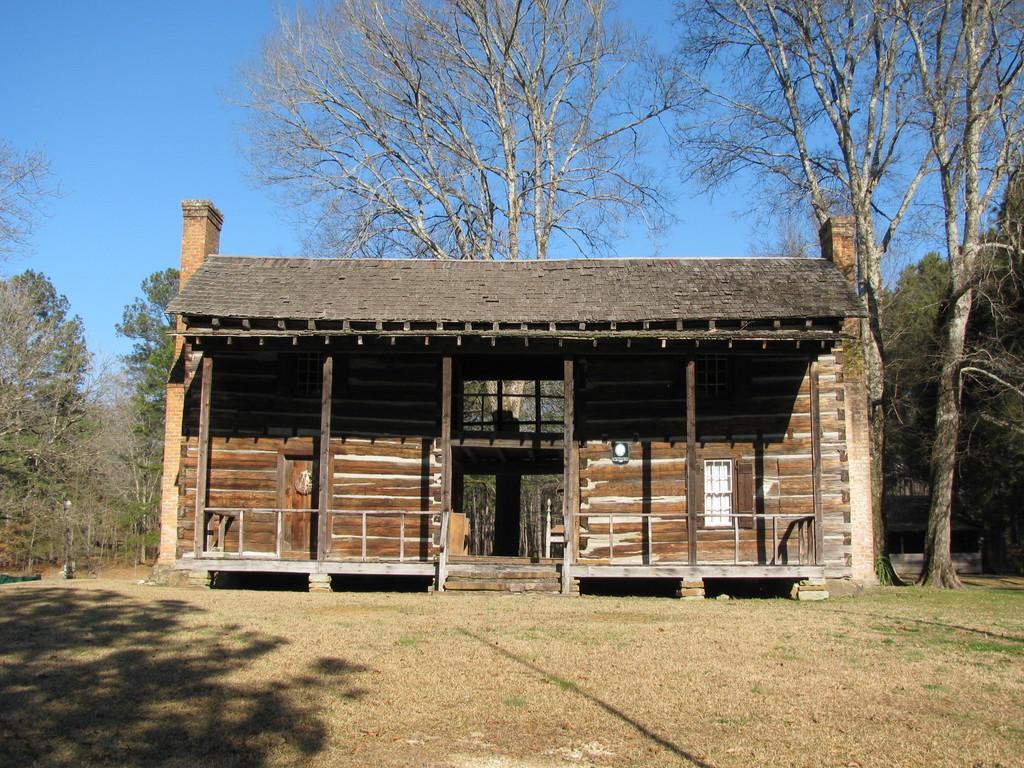Can you describe this image briefly? In this image I can see the ground, some grass, a house which is brown, white and grey in color and few trees. In the background I can see few trees and the sky. 